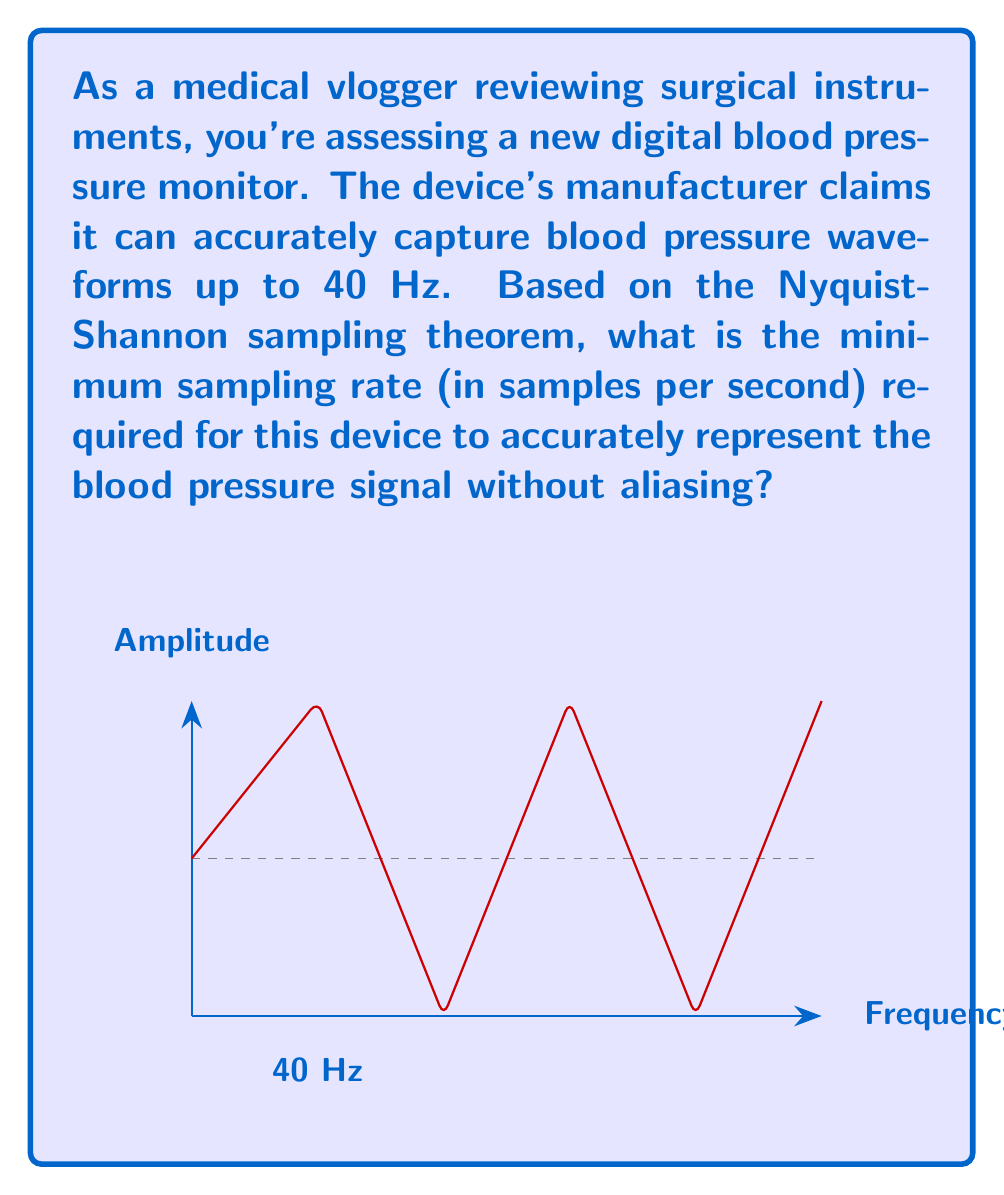Can you answer this question? To determine the optimal sampling rate for digital medical instruments using the Fourier transform, we need to apply the Nyquist-Shannon sampling theorem. This theorem states that to accurately reconstruct a continuous signal from its samples, the sampling rate must be at least twice the highest frequency component in the signal.

Step 1: Identify the highest frequency component in the signal.
From the question, we know that the blood pressure monitor can capture waveforms up to 40 Hz.

Step 2: Apply the Nyquist-Shannon sampling theorem.
The minimum sampling rate ($$f_s$$) is given by:

$$f_s = 2 \times f_{max}$$

Where $$f_{max}$$ is the maximum frequency component in the signal.

Step 3: Calculate the minimum sampling rate.
$$f_s = 2 \times 40\text{ Hz} = 80\text{ Hz}$$

Therefore, the minimum sampling rate required is 80 samples per second.

This sampling rate ensures that the blood pressure signal can be accurately reconstructed without aliasing, which could lead to misinterpretation of the medical data.
Answer: 80 Hz 